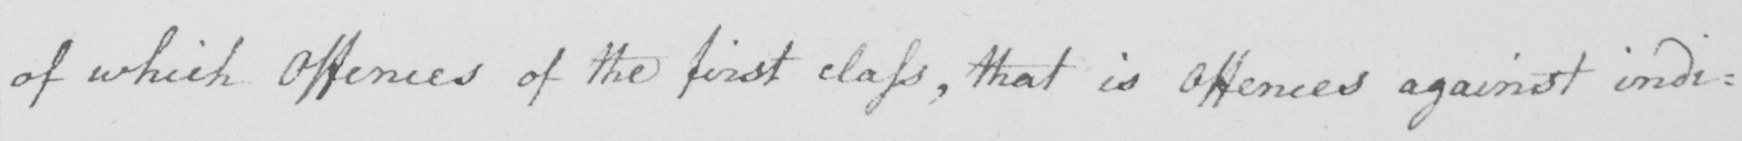What does this handwritten line say? of which Offences of the first class  , that is Offences against indi : 